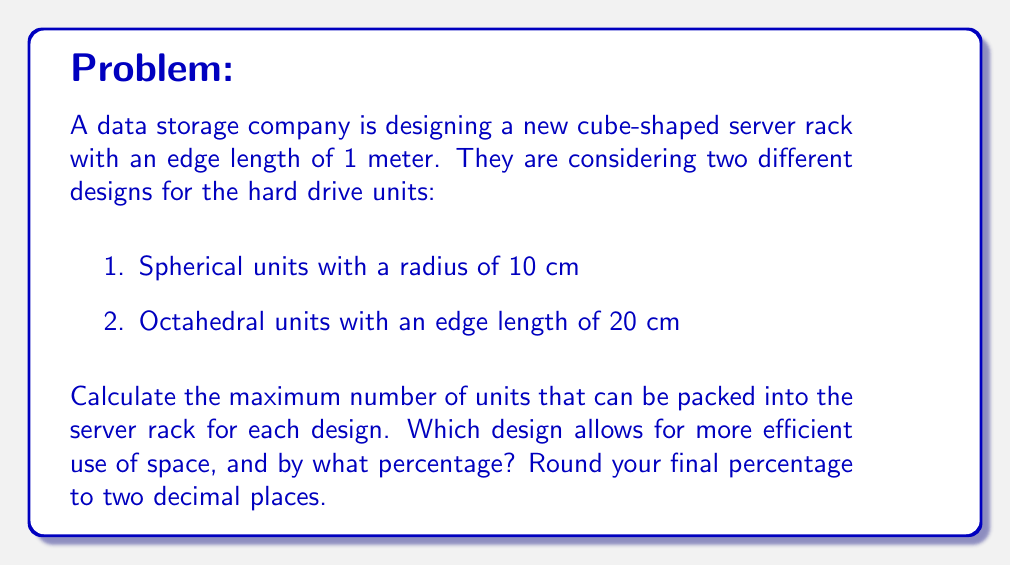Show me your answer to this math problem. Let's approach this problem step by step:

1. Spherical units:
   The volume of a sphere is given by $V_{sphere} = \frac{4}{3}\pi r^3$
   With $r = 10$ cm $= 0.1$ m, we have:
   $V_{sphere} = \frac{4}{3}\pi (0.1)^3 = 0.004188790$ m³

   The volume of the cube is $V_{cube} = 1^3 = 1$ m³

   Maximum number of spheres = $\lfloor \frac{V_{cube}}{V_{sphere}} \rfloor = \lfloor \frac{1}{0.004188790} \rfloor = 238$

   However, this is the theoretical maximum. The actual packing efficiency of spheres in a cube is about 74% of this value.
   Actual number of spheres $\approx 238 \times 0.74 = 176$

2. Octahedral units:
   The volume of an octahedron is given by $V_{octahedron} = \frac{\sqrt{2}}{3}a^3$
   Where $a$ is the edge length. With $a = 20$ cm $= 0.2$ m, we have:
   $V_{octahedron} = \frac{\sqrt{2}}{3}(0.2)^3 = 0.003771236$ m³

   Maximum number of octahedra = $\lfloor \frac{V_{cube}}{V_{octahedron}} \rfloor = \lfloor \frac{1}{0.003771236} \rfloor = 265$

3. Comparison:
   Octahedral design: 265 units
   Spherical design: 176 units

   Percentage difference = $\frac{265 - 176}{176} \times 100\% = 50.57\%$

Therefore, the octahedral design allows for 50.57% more units to be packed into the server rack compared to the spherical design.
Answer: The octahedral design is more efficient, allowing for 265 units compared to 176 units for the spherical design. The octahedral design is 50.57% more space-efficient. 